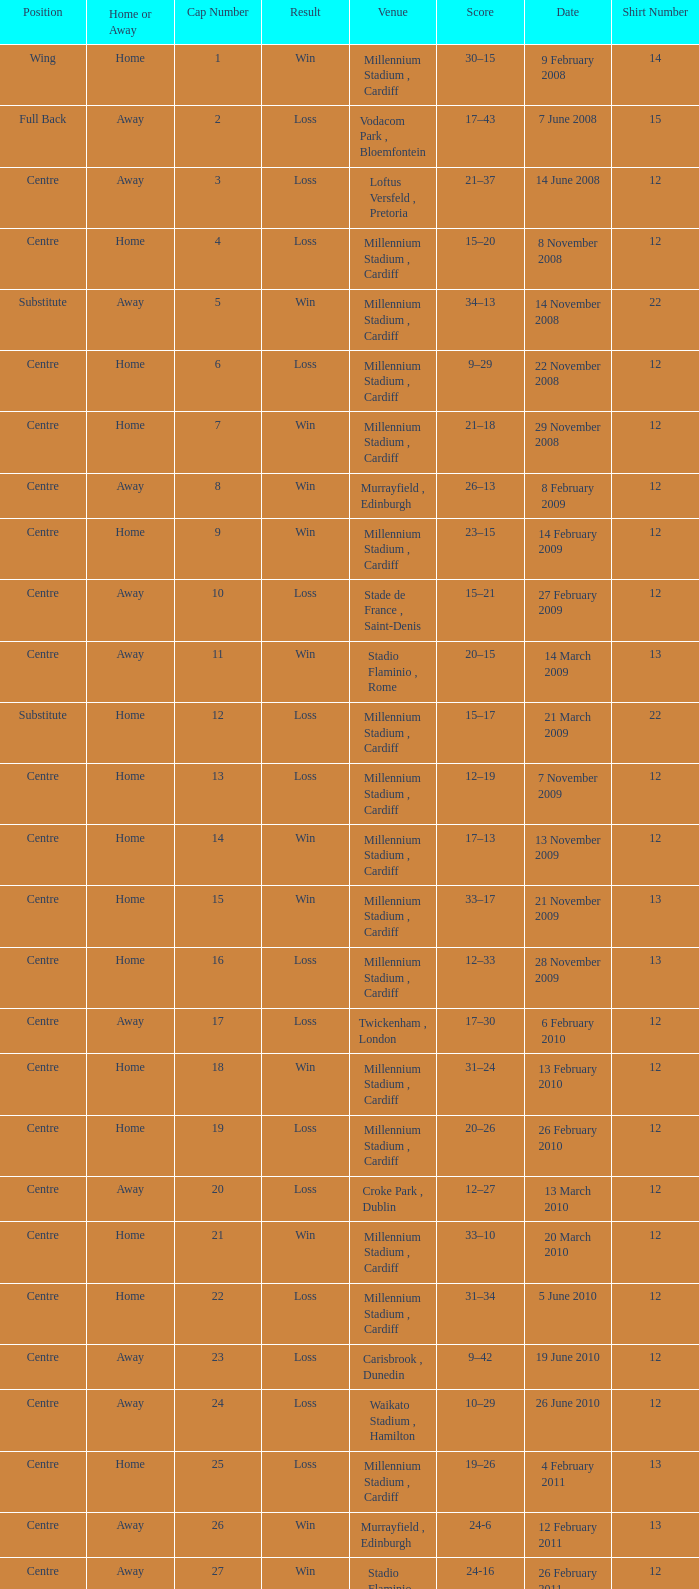What's the largest shirt number when the cap number is 5? 22.0. 